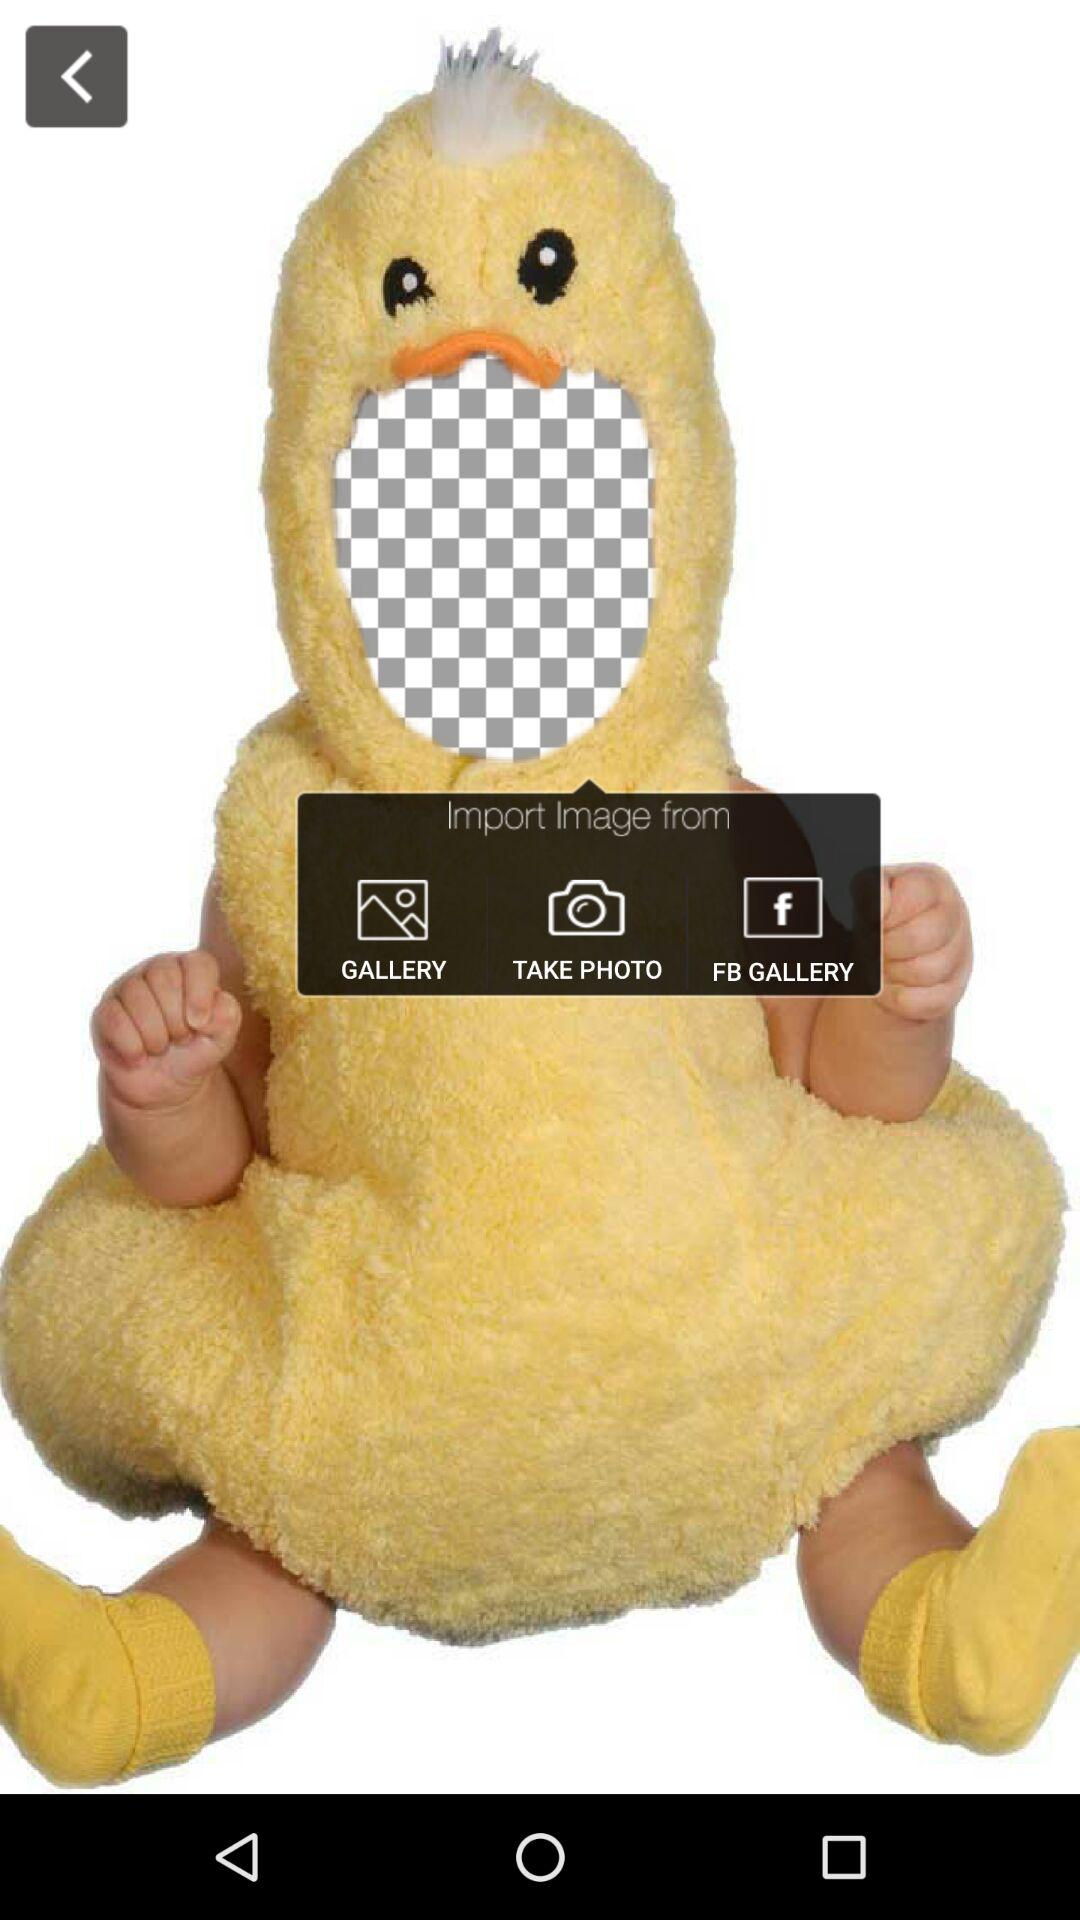How many images can be imported?
When the provided information is insufficient, respond with <no answer>. <no answer> 